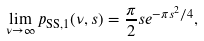Convert formula to latex. <formula><loc_0><loc_0><loc_500><loc_500>\lim _ { \nu \rightarrow \infty } p _ { \text {SS,} 1 } ( \nu , s ) = \frac { \pi } { 2 } s e ^ { - \pi s ^ { 2 } / 4 } ,</formula> 